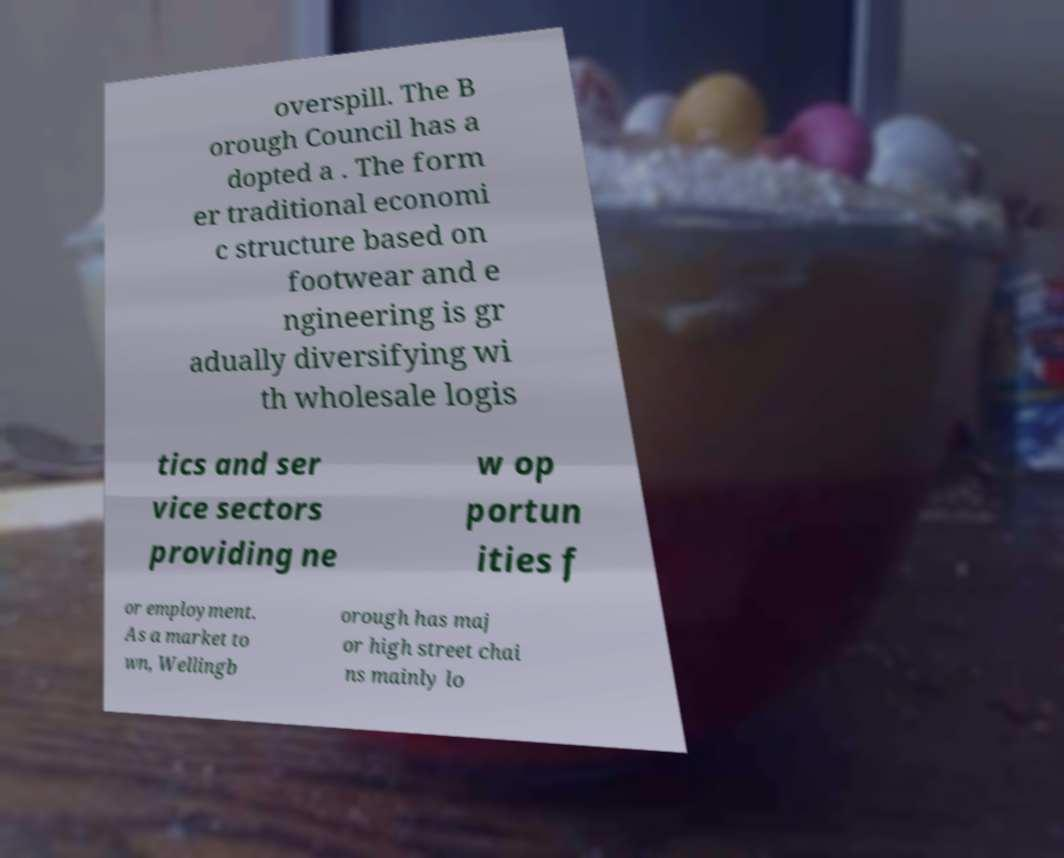Please identify and transcribe the text found in this image. overspill. The B orough Council has a dopted a . The form er traditional economi c structure based on footwear and e ngineering is gr adually diversifying wi th wholesale logis tics and ser vice sectors providing ne w op portun ities f or employment. As a market to wn, Wellingb orough has maj or high street chai ns mainly lo 